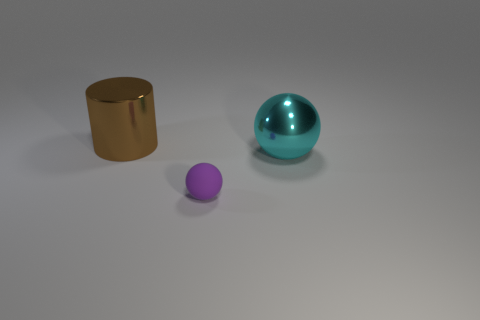Add 1 big green cubes. How many objects exist? 4 Subtract all balls. How many objects are left? 1 Subtract all large gray metallic cylinders. Subtract all big things. How many objects are left? 1 Add 1 small matte objects. How many small matte objects are left? 2 Add 2 small brown rubber objects. How many small brown rubber objects exist? 2 Subtract 0 blue blocks. How many objects are left? 3 